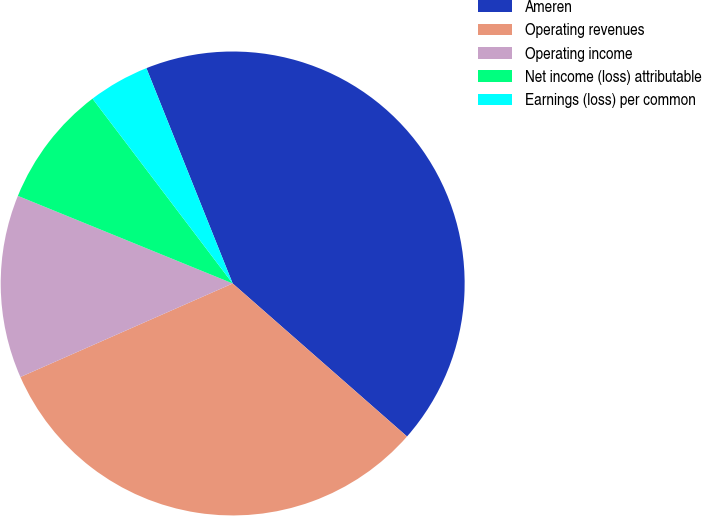<chart> <loc_0><loc_0><loc_500><loc_500><pie_chart><fcel>Ameren<fcel>Operating revenues<fcel>Operating income<fcel>Net income (loss) attributable<fcel>Earnings (loss) per common<nl><fcel>42.53%<fcel>31.93%<fcel>12.77%<fcel>8.51%<fcel>4.26%<nl></chart> 